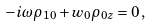Convert formula to latex. <formula><loc_0><loc_0><loc_500><loc_500>- i \omega \rho _ { 1 0 } + w _ { 0 } \rho _ { 0 z } = 0 \, ,</formula> 